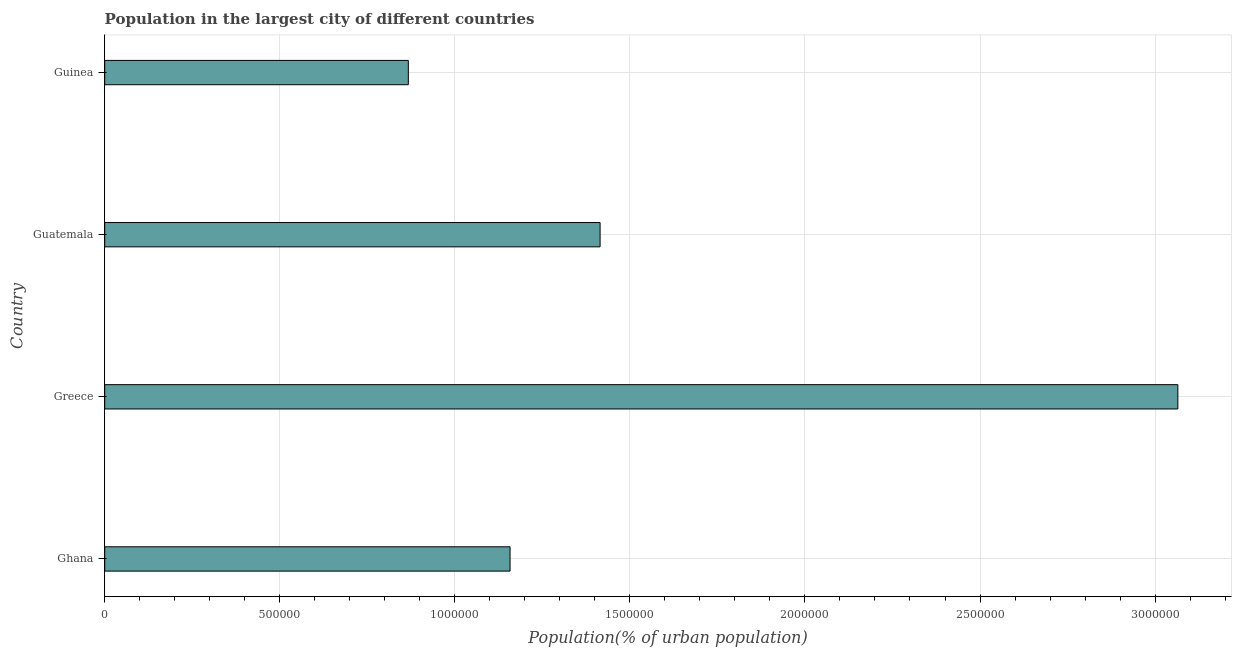Does the graph contain grids?
Make the answer very short. Yes. What is the title of the graph?
Offer a very short reply. Population in the largest city of different countries. What is the label or title of the X-axis?
Offer a terse response. Population(% of urban population). What is the population in largest city in Ghana?
Give a very brief answer. 1.16e+06. Across all countries, what is the maximum population in largest city?
Ensure brevity in your answer.  3.07e+06. Across all countries, what is the minimum population in largest city?
Make the answer very short. 8.67e+05. In which country was the population in largest city maximum?
Your answer should be compact. Greece. In which country was the population in largest city minimum?
Offer a terse response. Guinea. What is the sum of the population in largest city?
Ensure brevity in your answer.  6.50e+06. What is the difference between the population in largest city in Ghana and Greece?
Your answer should be compact. -1.91e+06. What is the average population in largest city per country?
Provide a succinct answer. 1.63e+06. What is the median population in largest city?
Make the answer very short. 1.29e+06. In how many countries, is the population in largest city greater than 2500000 %?
Offer a very short reply. 1. What is the ratio of the population in largest city in Ghana to that in Guatemala?
Provide a short and direct response. 0.82. Is the population in largest city in Greece less than that in Guatemala?
Your answer should be compact. No. What is the difference between the highest and the second highest population in largest city?
Give a very brief answer. 1.65e+06. Is the sum of the population in largest city in Greece and Guatemala greater than the maximum population in largest city across all countries?
Provide a succinct answer. Yes. What is the difference between the highest and the lowest population in largest city?
Your answer should be very brief. 2.20e+06. Are all the bars in the graph horizontal?
Ensure brevity in your answer.  Yes. Are the values on the major ticks of X-axis written in scientific E-notation?
Offer a terse response. No. What is the Population(% of urban population) of Ghana?
Offer a very short reply. 1.16e+06. What is the Population(% of urban population) in Greece?
Offer a very short reply. 3.07e+06. What is the Population(% of urban population) in Guatemala?
Provide a short and direct response. 1.41e+06. What is the Population(% of urban population) in Guinea?
Offer a very short reply. 8.67e+05. What is the difference between the Population(% of urban population) in Ghana and Greece?
Provide a succinct answer. -1.91e+06. What is the difference between the Population(% of urban population) in Ghana and Guatemala?
Offer a terse response. -2.57e+05. What is the difference between the Population(% of urban population) in Ghana and Guinea?
Make the answer very short. 2.91e+05. What is the difference between the Population(% of urban population) in Greece and Guatemala?
Ensure brevity in your answer.  1.65e+06. What is the difference between the Population(% of urban population) in Greece and Guinea?
Offer a very short reply. 2.20e+06. What is the difference between the Population(% of urban population) in Guatemala and Guinea?
Ensure brevity in your answer.  5.48e+05. What is the ratio of the Population(% of urban population) in Ghana to that in Greece?
Offer a very short reply. 0.38. What is the ratio of the Population(% of urban population) in Ghana to that in Guatemala?
Provide a succinct answer. 0.82. What is the ratio of the Population(% of urban population) in Ghana to that in Guinea?
Your answer should be very brief. 1.33. What is the ratio of the Population(% of urban population) in Greece to that in Guatemala?
Offer a very short reply. 2.17. What is the ratio of the Population(% of urban population) in Greece to that in Guinea?
Your answer should be compact. 3.54. What is the ratio of the Population(% of urban population) in Guatemala to that in Guinea?
Your response must be concise. 1.63. 